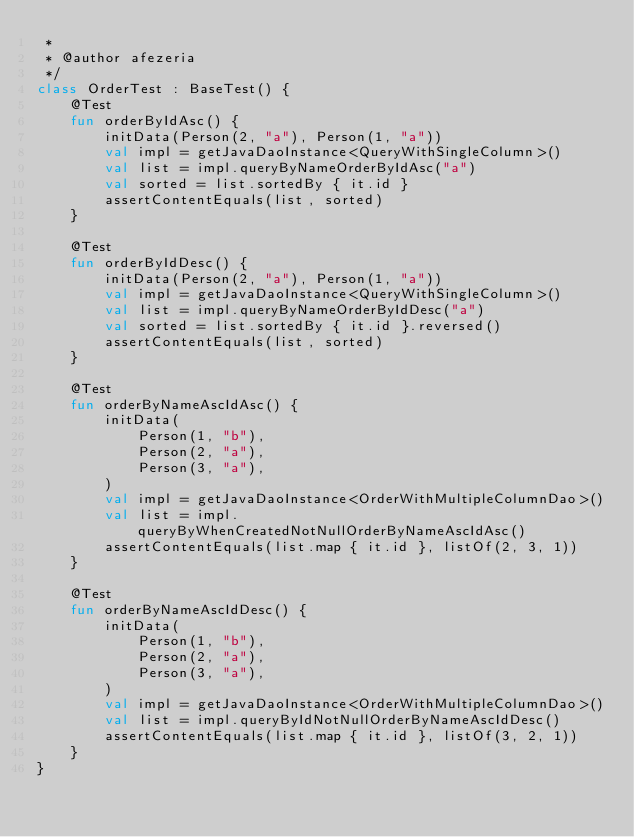Convert code to text. <code><loc_0><loc_0><loc_500><loc_500><_Kotlin_> *
 * @author afezeria
 */
class OrderTest : BaseTest() {
    @Test
    fun orderByIdAsc() {
        initData(Person(2, "a"), Person(1, "a"))
        val impl = getJavaDaoInstance<QueryWithSingleColumn>()
        val list = impl.queryByNameOrderByIdAsc("a")
        val sorted = list.sortedBy { it.id }
        assertContentEquals(list, sorted)
    }

    @Test
    fun orderByIdDesc() {
        initData(Person(2, "a"), Person(1, "a"))
        val impl = getJavaDaoInstance<QueryWithSingleColumn>()
        val list = impl.queryByNameOrderByIdDesc("a")
        val sorted = list.sortedBy { it.id }.reversed()
        assertContentEquals(list, sorted)
    }

    @Test
    fun orderByNameAscIdAsc() {
        initData(
            Person(1, "b"),
            Person(2, "a"),
            Person(3, "a"),
        )
        val impl = getJavaDaoInstance<OrderWithMultipleColumnDao>()
        val list = impl.queryByWhenCreatedNotNullOrderByNameAscIdAsc()
        assertContentEquals(list.map { it.id }, listOf(2, 3, 1))
    }

    @Test
    fun orderByNameAscIdDesc() {
        initData(
            Person(1, "b"),
            Person(2, "a"),
            Person(3, "a"),
        )
        val impl = getJavaDaoInstance<OrderWithMultipleColumnDao>()
        val list = impl.queryByIdNotNullOrderByNameAscIdDesc()
        assertContentEquals(list.map { it.id }, listOf(3, 2, 1))
    }
}</code> 